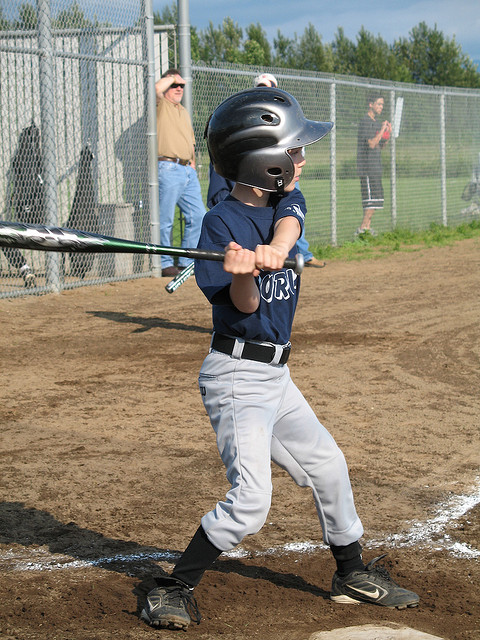Please identify all text content in this image. OR 